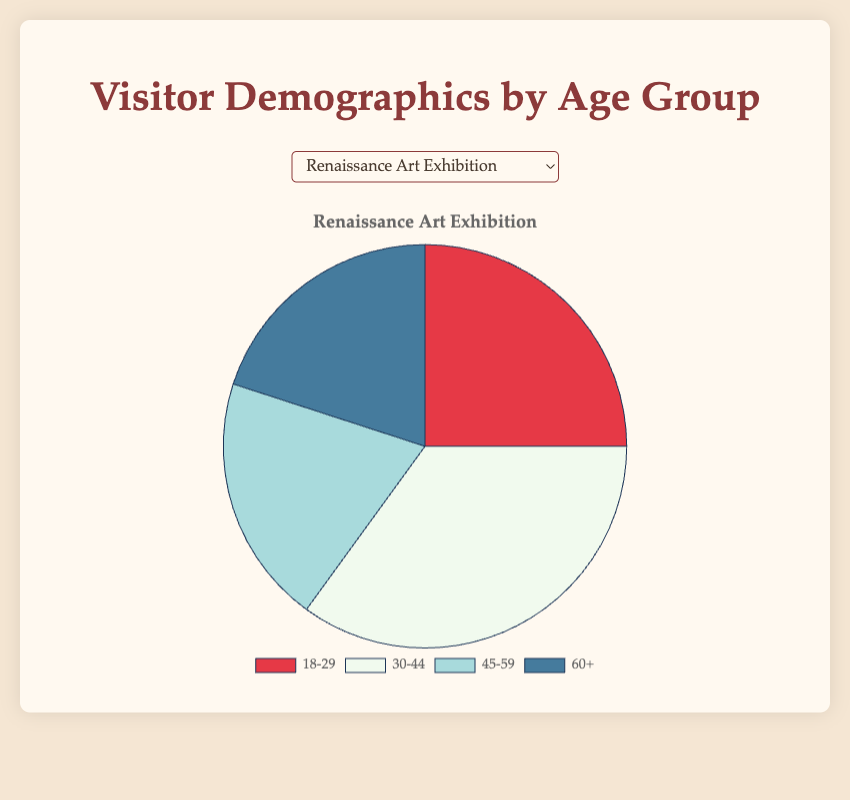Which age group had the highest number of visitors for the Renaissance Art Exhibition? For the Renaissance Art Exhibition, the age group 30-44 had the highest number of visitors with 35.
Answer: 30-44 Which event had the highest percentage of visitors aged 18-29? The 'Wine and Art Night' had the highest percentage of visitors aged 18-29 with 40 attendees.
Answer: Wine and Art Night What's the total number of visitors aged 45-59 across all events? Summing up the visitors aged 45-59 for all events: 20 + 15 + 30 + 25 + 20 = 110.
Answer: 110 Compare the number of visitors aged 60+ for the Modern Sculpture Showcase and the Impressionist Paintings Display. The Modern Sculpture Showcase had 15 visitors aged 60+ while the Impressionist Paintings Display had 25. Therefore, 25 - 15 = 10 more visitors were aged 60+ at the Impressionist Paintings Display.
Answer: 10 Which event had the least number of visitors aged 60+? The 'Wine and Art Night' had the least number of visitors aged 60+ with just 10 attendees.
Answer: Wine and Art Night What is the difference between the number of visitors aged 18-29 and 60+ at the Wine and Art Night? At the Wine and Art Night, 18-29 had 40 visitors and 60+ had 10 visitors. The difference is 40 - 10 = 30.
Answer: 30 What percentage of the total visitors for the Ancient Artifacts Exhibition were aged 30-44? The total number of visitors for the Ancient Artifacts Exhibition is 15 + 25 + 30 + 30 = 100. Visitors aged 30-44 are 25. Thus, the percentage is (25/100)*100 = 25%.
Answer: 25% What is the combined number of visitors aged 18-29 and 30-44 for the Impressionist Paintings Display? For the Impressionist Paintings Display, visitors 18-29 are 20 and 30-44 are 30. Combining them gives 20 + 30 = 50.
Answer: 50 How does the proportion of visitors aged 45-59 compare to those aged 60+ at the Renaissance Art Exhibition? Both age groups 45-59 and 60+ at the Renaissance Art Exhibition had 20 visitors each, so their proportions are equal.
Answer: Equal What's the average number of visitors aged 18-29 across all events? Summing up the visitors aged 18-29 for all events: 25 + 30 + 15 + 20 + 40 = 130. There are 5 events, so the average is 130 / 5 = 26.
Answer: 26 